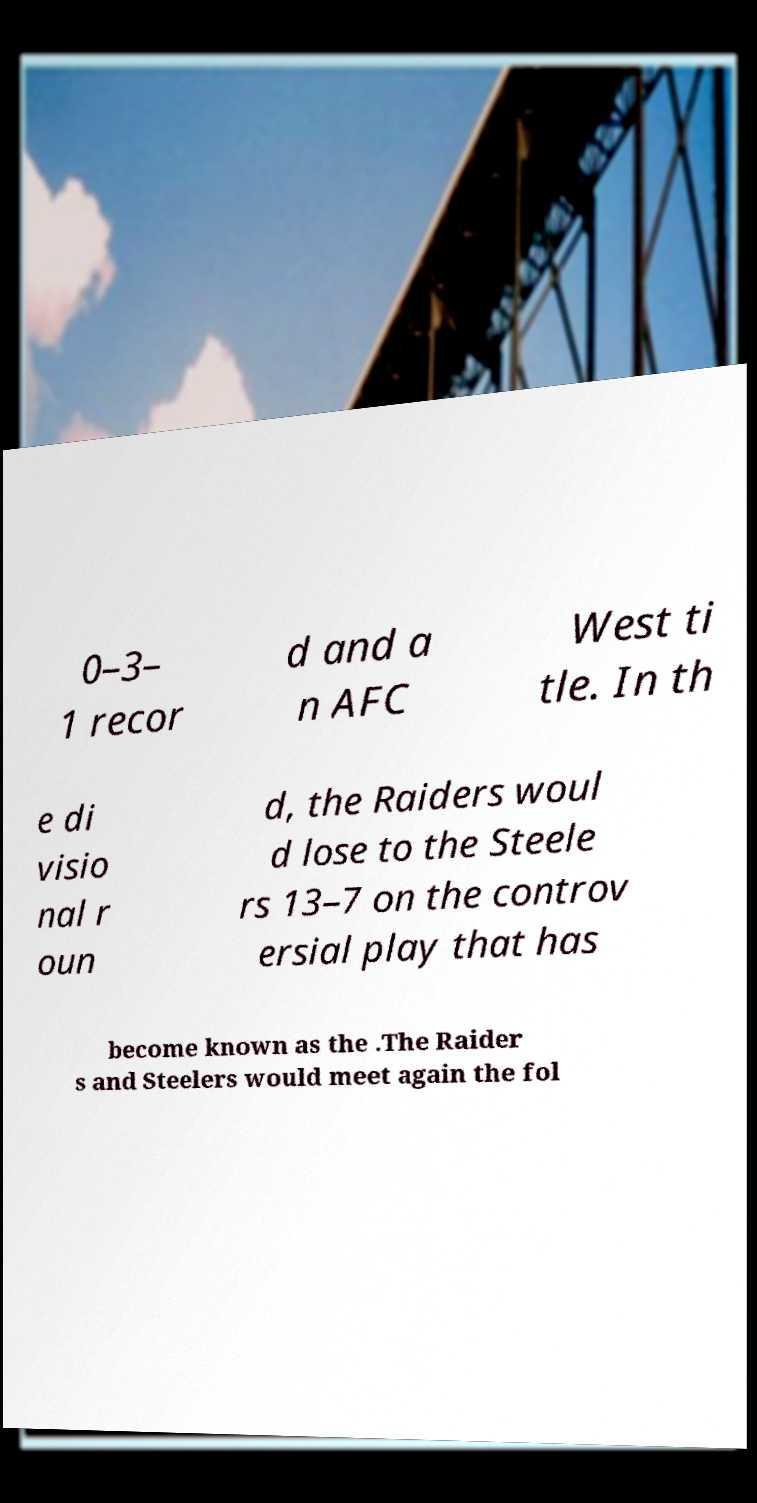I need the written content from this picture converted into text. Can you do that? 0–3– 1 recor d and a n AFC West ti tle. In th e di visio nal r oun d, the Raiders woul d lose to the Steele rs 13–7 on the controv ersial play that has become known as the .The Raider s and Steelers would meet again the fol 